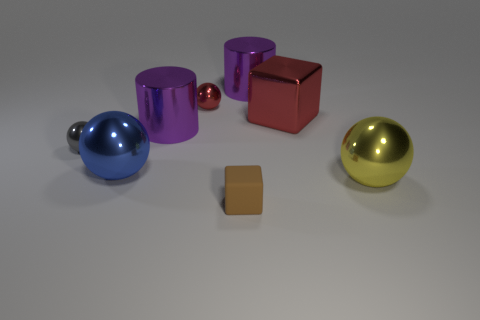How many gray things are large metallic cylinders or big shiny cubes?
Ensure brevity in your answer.  0. There is a cube that is made of the same material as the gray ball; what is its color?
Your response must be concise. Red. How many big objects are either metallic cylinders or yellow rubber things?
Offer a very short reply. 2. Are there fewer rubber things than shiny things?
Your answer should be compact. Yes. There is another matte thing that is the same shape as the big red object; what color is it?
Keep it short and to the point. Brown. Are there any other things that have the same shape as the blue metallic object?
Your answer should be compact. Yes. Is the number of tiny metallic spheres greater than the number of tiny objects?
Provide a short and direct response. No. How many other objects are there of the same material as the brown thing?
Provide a short and direct response. 0. The red shiny thing right of the small object in front of the tiny thing on the left side of the large blue object is what shape?
Offer a very short reply. Cube. Are there fewer big yellow metallic spheres that are on the right side of the red shiny cube than big objects that are left of the large yellow shiny ball?
Your response must be concise. Yes. 